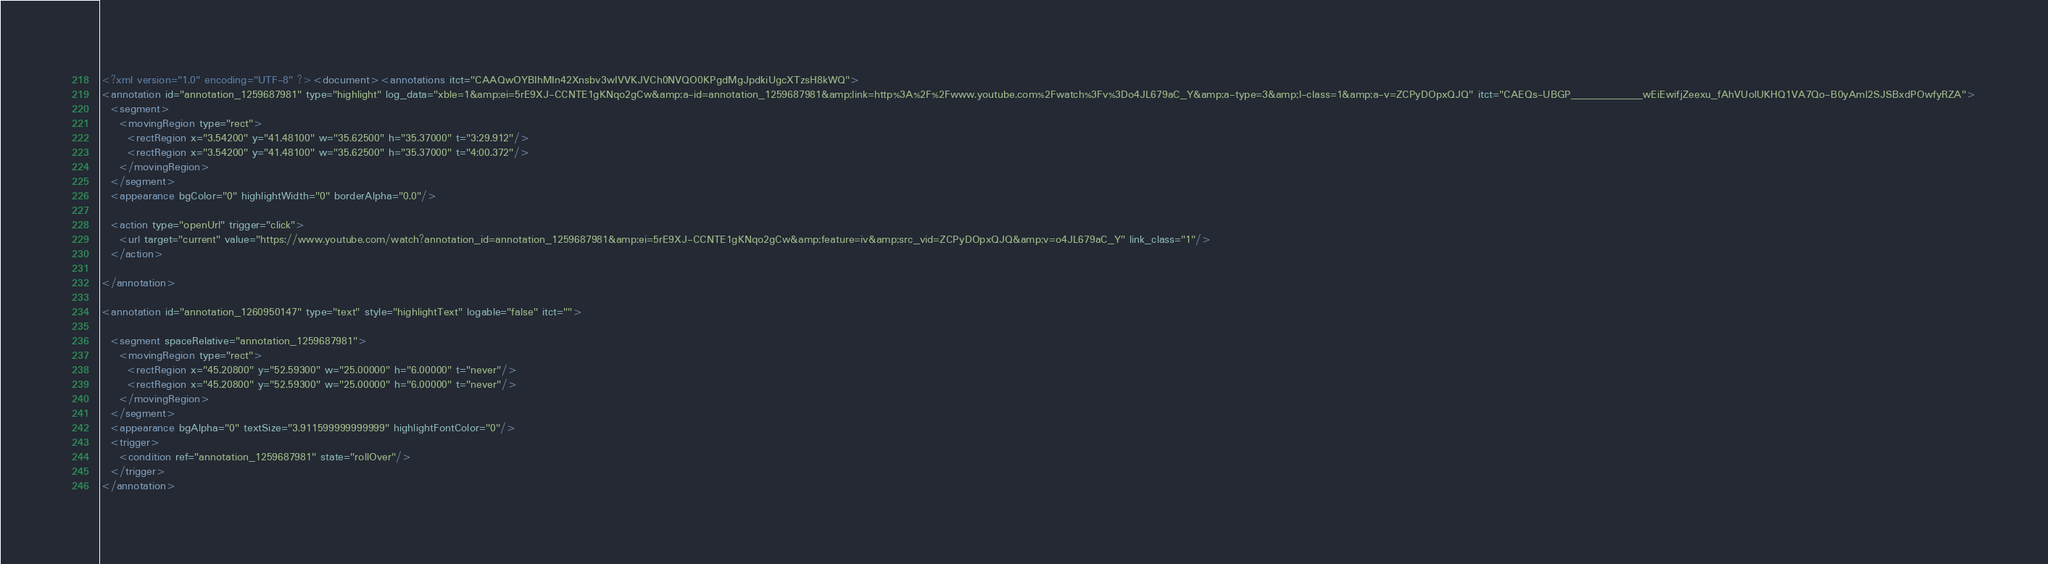<code> <loc_0><loc_0><loc_500><loc_500><_XML_><?xml version="1.0" encoding="UTF-8" ?><document><annotations itct="CAAQwOYBIhMIn42Xnsbv3wIVVKJVCh0NVQO0KPgdMgJpdkiUgcXTzsH8kWQ">
<annotation id="annotation_1259687981" type="highlight" log_data="xble=1&amp;ei=5rE9XJ-CCNTE1gKNqo2gCw&amp;a-id=annotation_1259687981&amp;link=http%3A%2F%2Fwww.youtube.com%2Fwatch%3Fv%3Do4JL679aC_Y&amp;a-type=3&amp;l-class=1&amp;a-v=ZCPyDOpxQJQ" itct="CAEQs-UBGP___________wEiEwifjZeexu_fAhVUolUKHQ1VA7Qo-B0yAml2SJSBxdPOwfyRZA">
  <segment>
    <movingRegion type="rect">
      <rectRegion x="3.54200" y="41.48100" w="35.62500" h="35.37000" t="3:29.912"/>
      <rectRegion x="3.54200" y="41.48100" w="35.62500" h="35.37000" t="4:00.372"/>
    </movingRegion>
  </segment>
  <appearance bgColor="0" highlightWidth="0" borderAlpha="0.0"/>
  
  <action type="openUrl" trigger="click">
    <url target="current" value="https://www.youtube.com/watch?annotation_id=annotation_1259687981&amp;ei=5rE9XJ-CCNTE1gKNqo2gCw&amp;feature=iv&amp;src_vid=ZCPyDOpxQJQ&amp;v=o4JL679aC_Y" link_class="1"/>
  </action>

</annotation>

<annotation id="annotation_1260950147" type="text" style="highlightText" logable="false" itct="">
  
  <segment spaceRelative="annotation_1259687981">
    <movingRegion type="rect">
      <rectRegion x="45.20800" y="52.59300" w="25.00000" h="6.00000" t="never"/>
      <rectRegion x="45.20800" y="52.59300" w="25.00000" h="6.00000" t="never"/>
    </movingRegion>
  </segment>
  <appearance bgAlpha="0" textSize="3.911599999999999" highlightFontColor="0"/>
  <trigger>
    <condition ref="annotation_1259687981" state="rollOver"/>
  </trigger>
</annotation>
</code> 